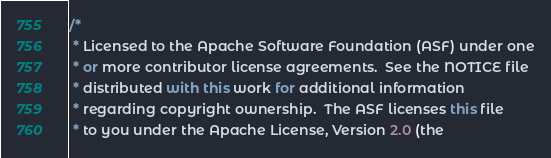<code> <loc_0><loc_0><loc_500><loc_500><_C#_>/*
 * Licensed to the Apache Software Foundation (ASF) under one
 * or more contributor license agreements.  See the NOTICE file
 * distributed with this work for additional information
 * regarding copyright ownership.  The ASF licenses this file
 * to you under the Apache License, Version 2.0 (the</code> 